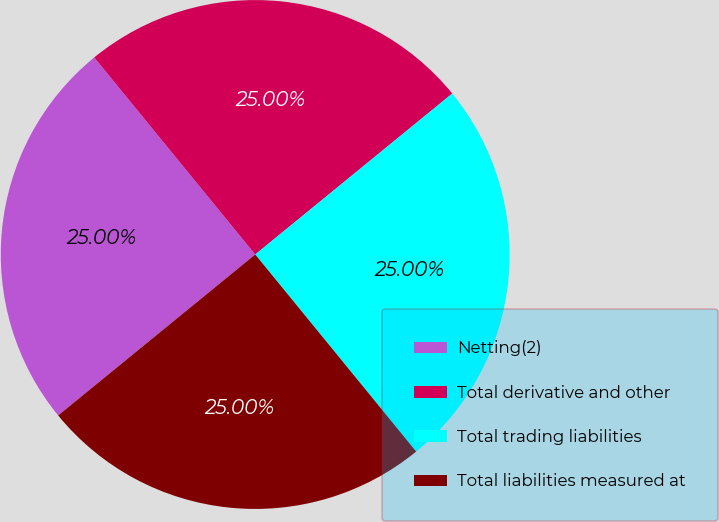<chart> <loc_0><loc_0><loc_500><loc_500><pie_chart><fcel>Netting(2)<fcel>Total derivative and other<fcel>Total trading liabilities<fcel>Total liabilities measured at<nl><fcel>25.0%<fcel>25.0%<fcel>25.0%<fcel>25.0%<nl></chart> 